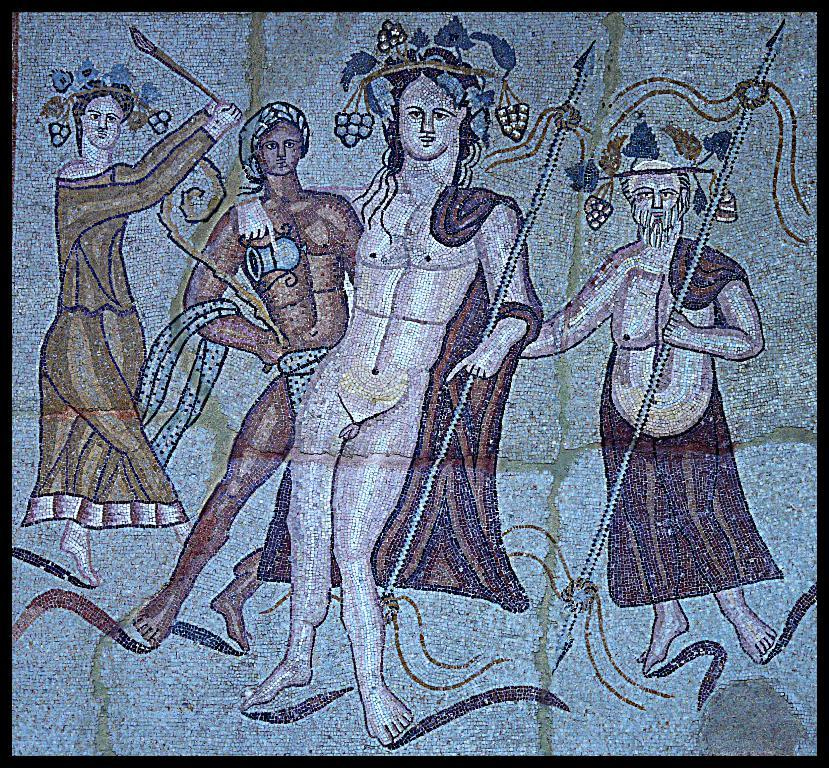What is on the wall in the image? There is a painting on the wall in the image. What can be seen in the painting? There are people depicted in the painting. What type of insurance is being sold in the painting? There is no indication of insurance being sold or discussed in the painting; it simply depicts people. 